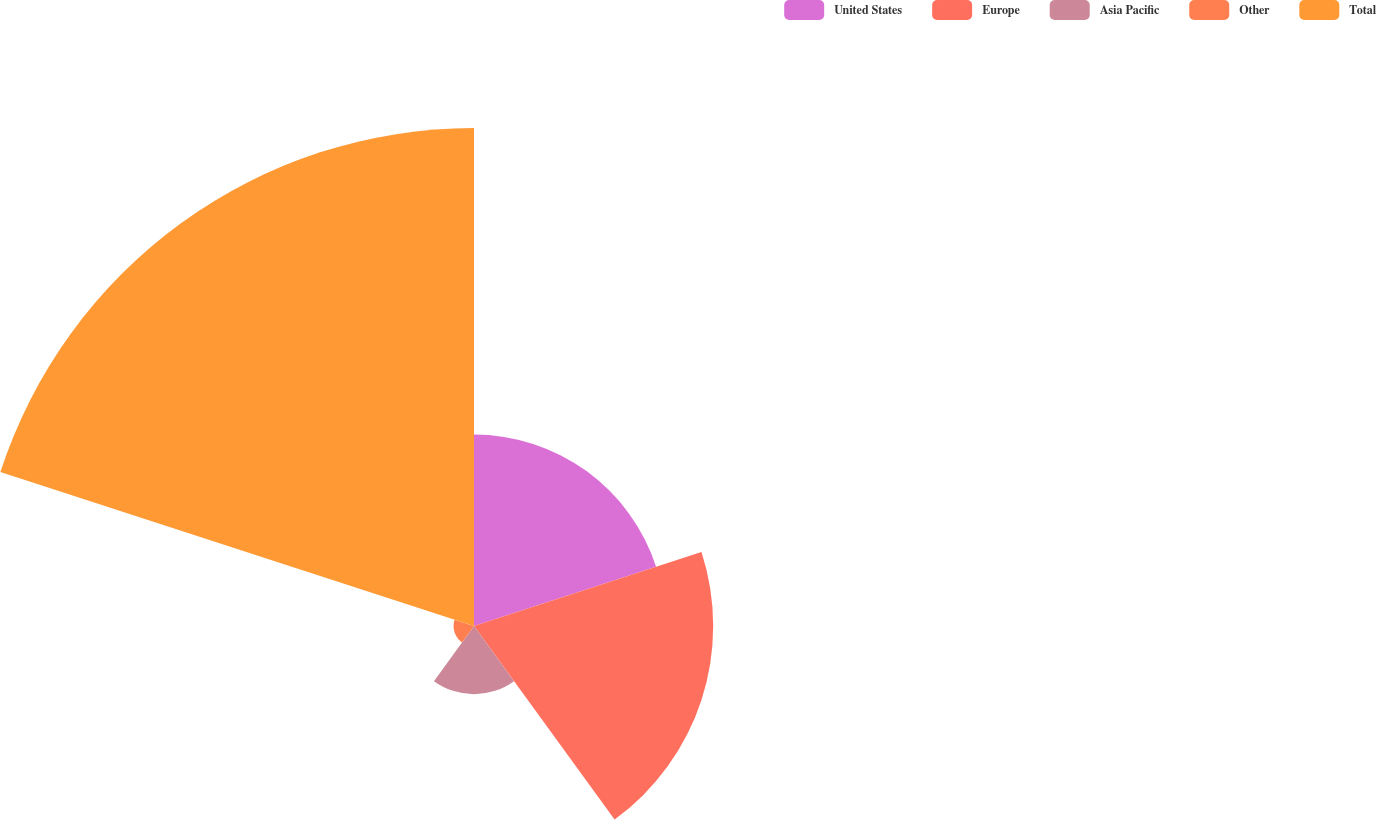Convert chart to OTSL. <chart><loc_0><loc_0><loc_500><loc_500><pie_chart><fcel>United States<fcel>Europe<fcel>Asia Pacific<fcel>Other<fcel>Total<nl><fcel>18.82%<fcel>23.51%<fcel>6.7%<fcel>2.01%<fcel>48.95%<nl></chart> 